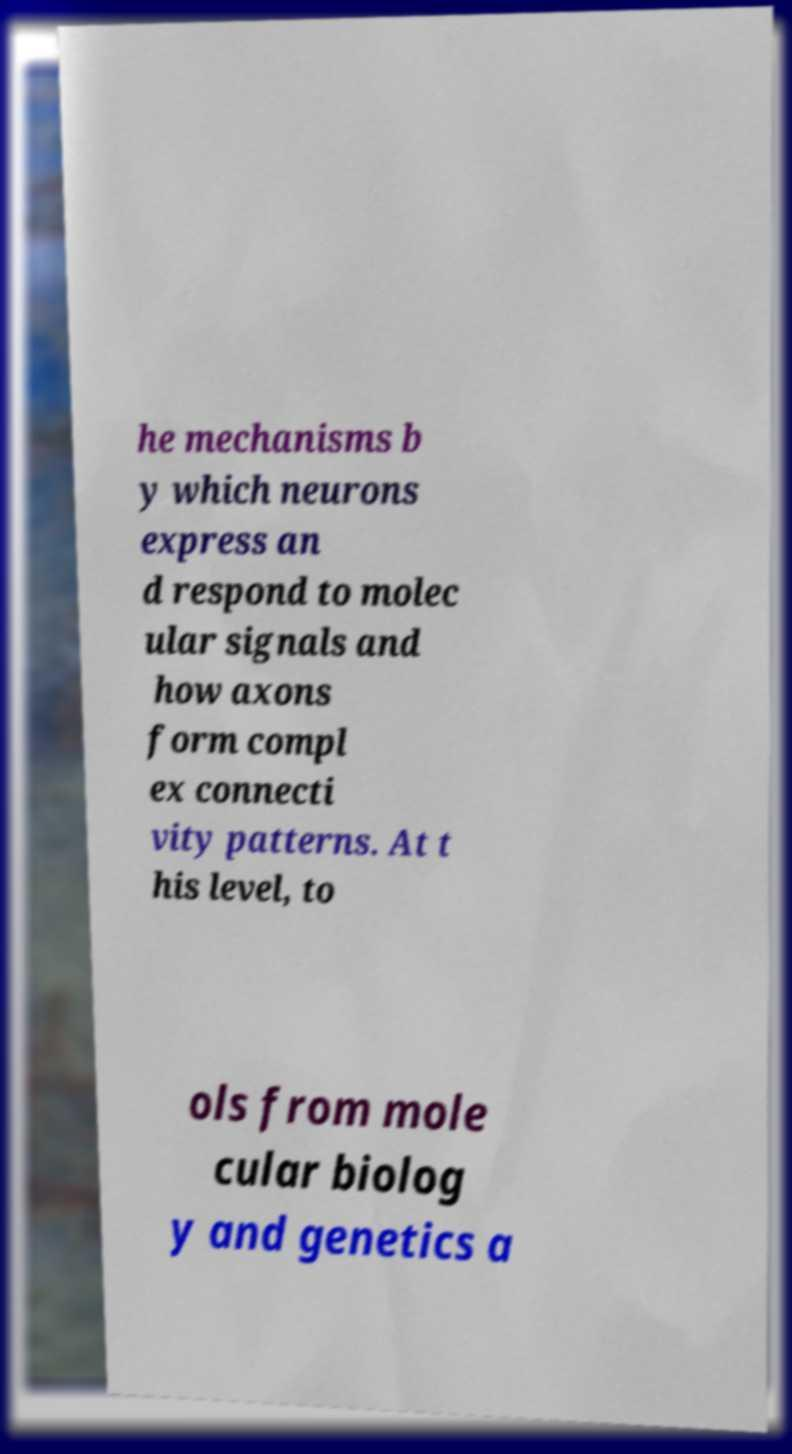Could you extract and type out the text from this image? he mechanisms b y which neurons express an d respond to molec ular signals and how axons form compl ex connecti vity patterns. At t his level, to ols from mole cular biolog y and genetics a 